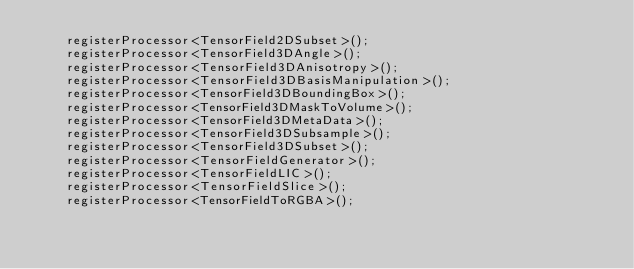<code> <loc_0><loc_0><loc_500><loc_500><_C++_>    registerProcessor<TensorField2DSubset>();
    registerProcessor<TensorField3DAngle>();
    registerProcessor<TensorField3DAnisotropy>();
    registerProcessor<TensorField3DBasisManipulation>();
    registerProcessor<TensorField3DBoundingBox>();
    registerProcessor<TensorField3DMaskToVolume>();
    registerProcessor<TensorField3DMetaData>();
    registerProcessor<TensorField3DSubsample>();
    registerProcessor<TensorField3DSubset>();
    registerProcessor<TensorFieldGenerator>();
    registerProcessor<TensorFieldLIC>();
    registerProcessor<TensorFieldSlice>();
    registerProcessor<TensorFieldToRGBA>();</code> 